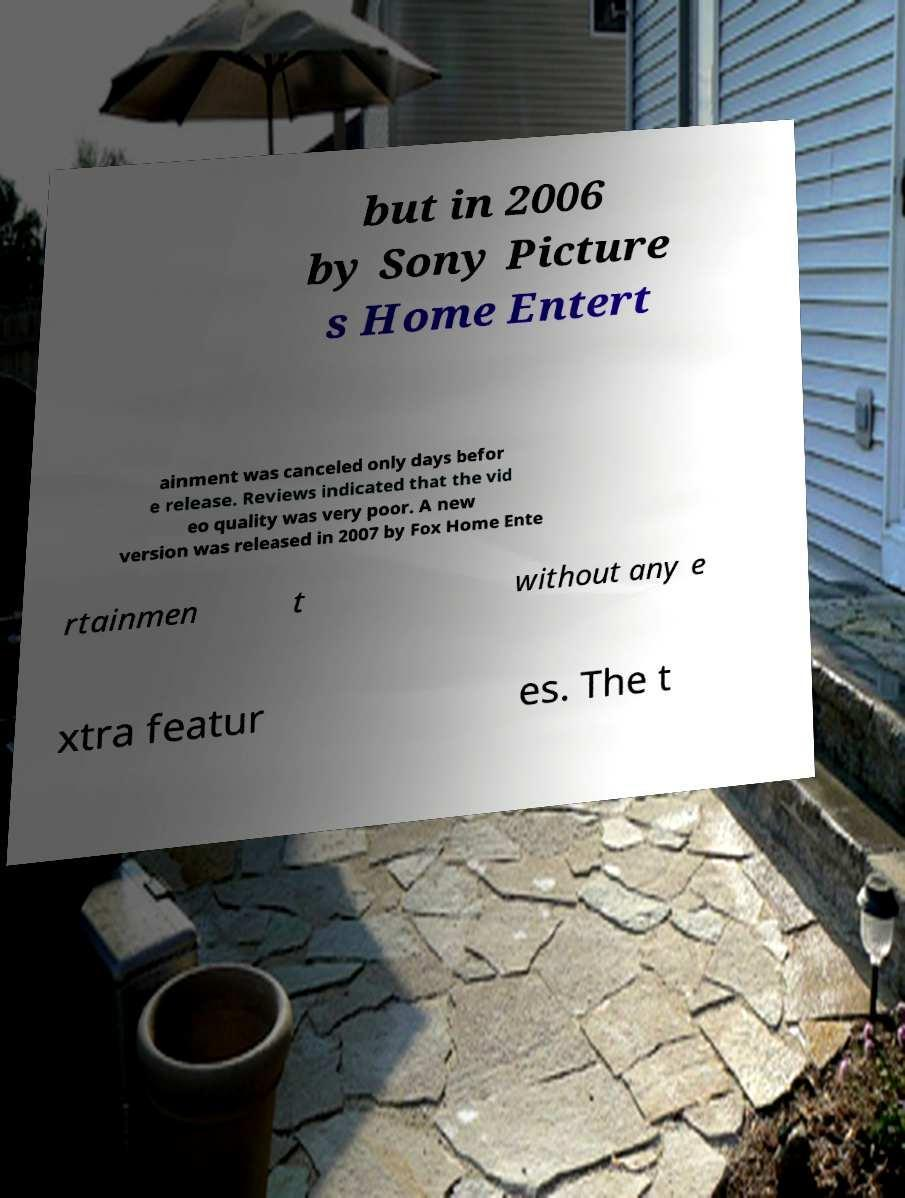For documentation purposes, I need the text within this image transcribed. Could you provide that? but in 2006 by Sony Picture s Home Entert ainment was canceled only days befor e release. Reviews indicated that the vid eo quality was very poor. A new version was released in 2007 by Fox Home Ente rtainmen t without any e xtra featur es. The t 